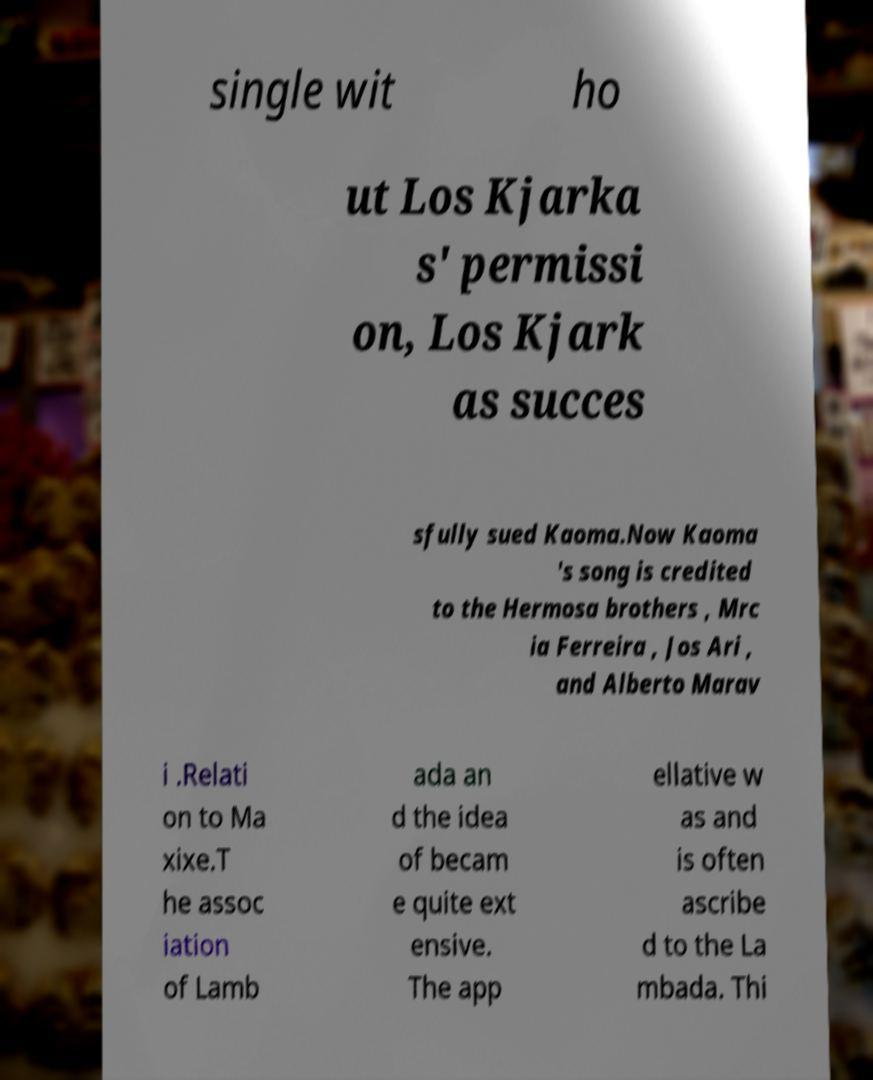I need the written content from this picture converted into text. Can you do that? single wit ho ut Los Kjarka s' permissi on, Los Kjark as succes sfully sued Kaoma.Now Kaoma 's song is credited to the Hermosa brothers , Mrc ia Ferreira , Jos Ari , and Alberto Marav i .Relati on to Ma xixe.T he assoc iation of Lamb ada an d the idea of becam e quite ext ensive. The app ellative w as and is often ascribe d to the La mbada. Thi 